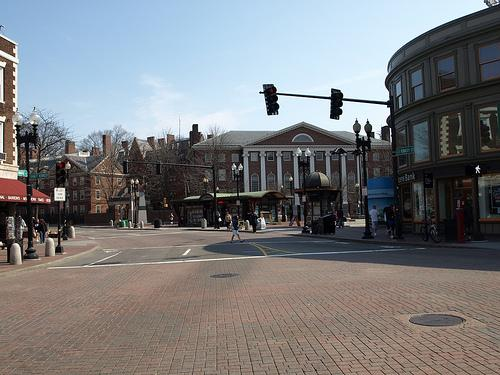What is the condition of the sky in the image? The sky is blue and mostly clear with a few clouds. Identify any trees in the image and describe their appearance. The trees in the background are bare. Can you find any person(s) in the image? If so, briefly describe their actions. There is a person walking on the sidewalk, a person in the crosswalk, and a man in a white t-shirt walking. Estimate the number of visible street lights in the picture. There are two street lights on one pole. Briefly describe the road in the image. The road is made of red bricks with a white crosswalk and two manholes. What are the characteristics of the building in the image? The building has a curved shape, white columns, a red awning, and a large brown and white structure. Pick out any prominent storefront in the image. There is a store on the corner with a red awning. Describe the scene revolving around a person wearing white shorts. The person wearing white shorts is crossing the street near the white crosswalk. Examine the image and list the colors of the traffic lights. There are two traffic lights which are both red. Mention the placement of an object in relation to the building. The traffic light is attached to the building. Locate the fountain in the center of the pedestrian walkway with a statue on it. No, it's not mentioned in the image. I'd like you to find the purple car parked next to the building with red awning. This is misleading because there are no mentions of a purple car or any cars parked next to the building with red awning. 